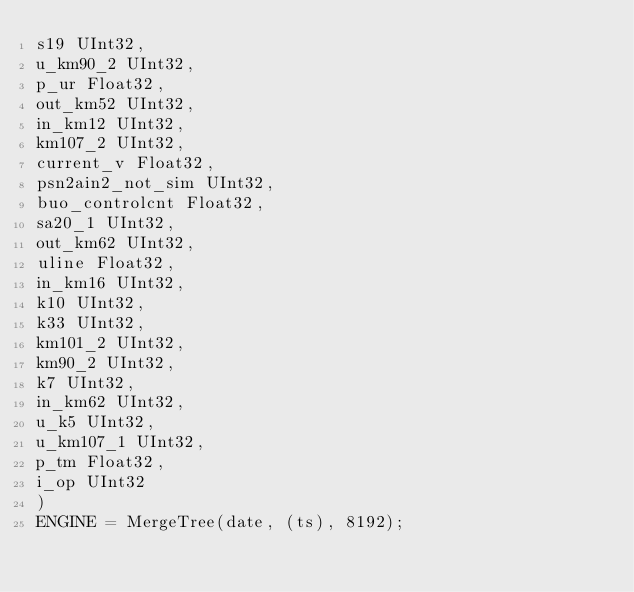<code> <loc_0><loc_0><loc_500><loc_500><_SQL_>s19 UInt32,
u_km90_2 UInt32,
p_ur Float32,
out_km52 UInt32,
in_km12 UInt32,
km107_2 UInt32,
current_v Float32,
psn2ain2_not_sim UInt32,
buo_controlcnt Float32,
sa20_1 UInt32,
out_km62 UInt32,
uline Float32,
in_km16 UInt32,
k10 UInt32,
k33 UInt32,
km101_2 UInt32,
km90_2 UInt32,
k7 UInt32,
in_km62 UInt32,
u_k5 UInt32,
u_km107_1 UInt32,
p_tm Float32,
i_op UInt32
)
ENGINE = MergeTree(date, (ts), 8192);</code> 